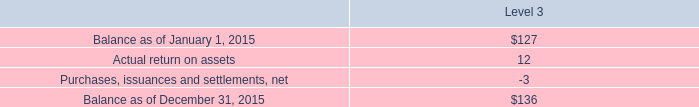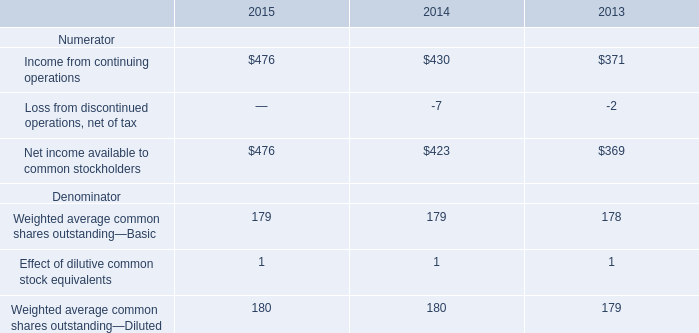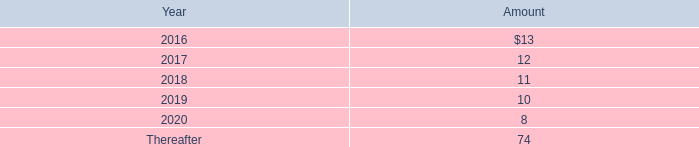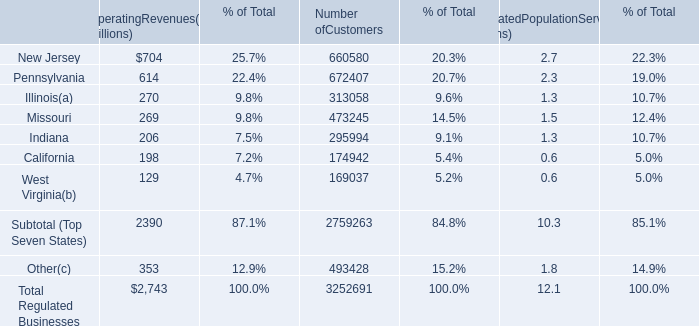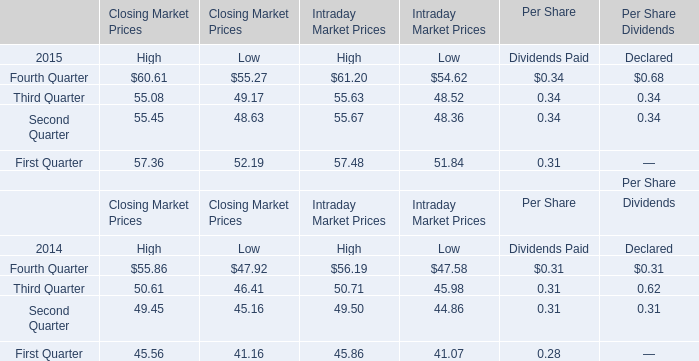what is the approximate customer penetration in the west virginia market area? 
Computations: (169037 / (0.6 * 1000000))
Answer: 0.28173. 